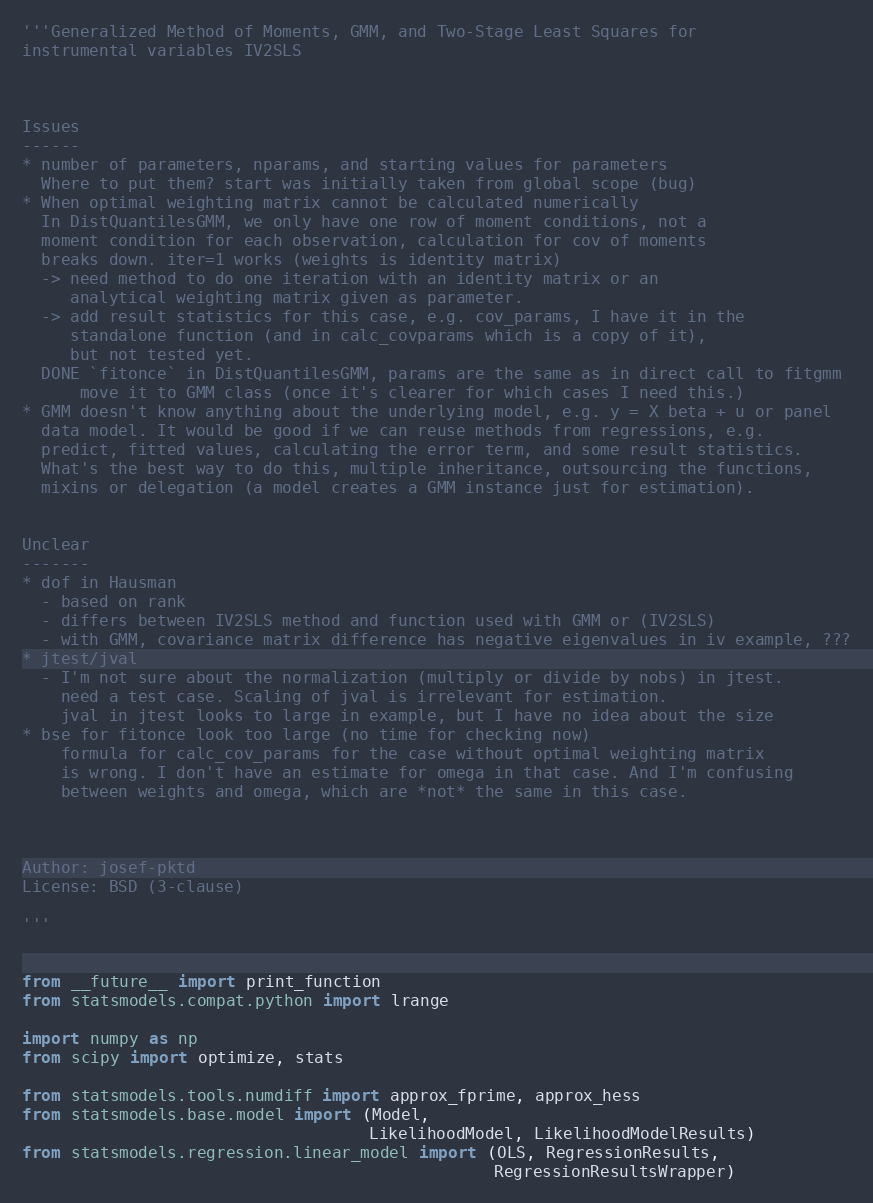Convert code to text. <code><loc_0><loc_0><loc_500><loc_500><_Python_>'''Generalized Method of Moments, GMM, and Two-Stage Least Squares for
instrumental variables IV2SLS



Issues
------
* number of parameters, nparams, and starting values for parameters
  Where to put them? start was initially taken from global scope (bug)
* When optimal weighting matrix cannot be calculated numerically
  In DistQuantilesGMM, we only have one row of moment conditions, not a
  moment condition for each observation, calculation for cov of moments
  breaks down. iter=1 works (weights is identity matrix)
  -> need method to do one iteration with an identity matrix or an
     analytical weighting matrix given as parameter.
  -> add result statistics for this case, e.g. cov_params, I have it in the
     standalone function (and in calc_covparams which is a copy of it),
     but not tested yet.
  DONE `fitonce` in DistQuantilesGMM, params are the same as in direct call to fitgmm
      move it to GMM class (once it's clearer for which cases I need this.)
* GMM doesn't know anything about the underlying model, e.g. y = X beta + u or panel
  data model. It would be good if we can reuse methods from regressions, e.g.
  predict, fitted values, calculating the error term, and some result statistics.
  What's the best way to do this, multiple inheritance, outsourcing the functions,
  mixins or delegation (a model creates a GMM instance just for estimation).


Unclear
-------
* dof in Hausman
  - based on rank
  - differs between IV2SLS method and function used with GMM or (IV2SLS)
  - with GMM, covariance matrix difference has negative eigenvalues in iv example, ???
* jtest/jval
  - I'm not sure about the normalization (multiply or divide by nobs) in jtest.
    need a test case. Scaling of jval is irrelevant for estimation.
    jval in jtest looks to large in example, but I have no idea about the size
* bse for fitonce look too large (no time for checking now)
    formula for calc_cov_params for the case without optimal weighting matrix
    is wrong. I don't have an estimate for omega in that case. And I'm confusing
    between weights and omega, which are *not* the same in this case.



Author: josef-pktd
License: BSD (3-clause)

'''


from __future__ import print_function
from statsmodels.compat.python import lrange

import numpy as np
from scipy import optimize, stats

from statsmodels.tools.numdiff import approx_fprime, approx_hess
from statsmodels.base.model import (Model,
                                    LikelihoodModel, LikelihoodModelResults)
from statsmodels.regression.linear_model import (OLS, RegressionResults,
                                                 RegressionResultsWrapper)</code> 